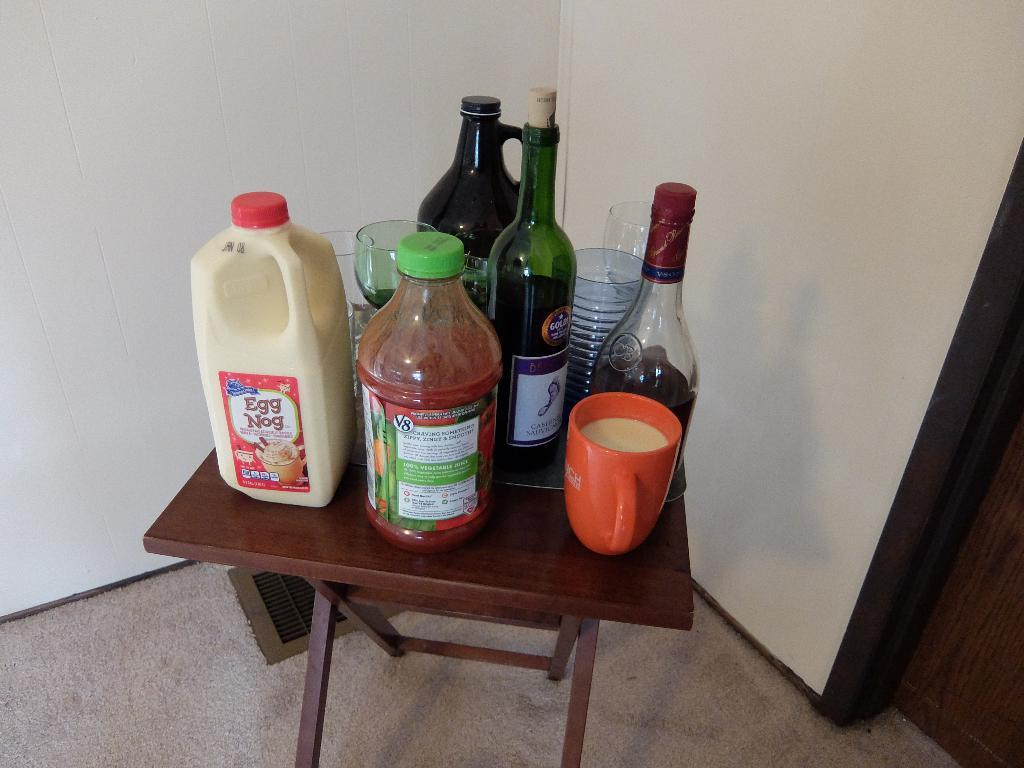What type of furniture is present in the image? There is a table in the image. What is placed on the table? There is a cup, wine bottles, a juice bottle, a wine glass, and a bottle labeled "Eggnog" on the table. How many types of beverages are visible on the table? There are three types of beverages visible on the table: wine, juice, and eggnog. Can you see any beetles crawling on the table in the image? There are no beetles present in the image. Is there a pocket on the table in the image? There is no pocket on the table in the image. 